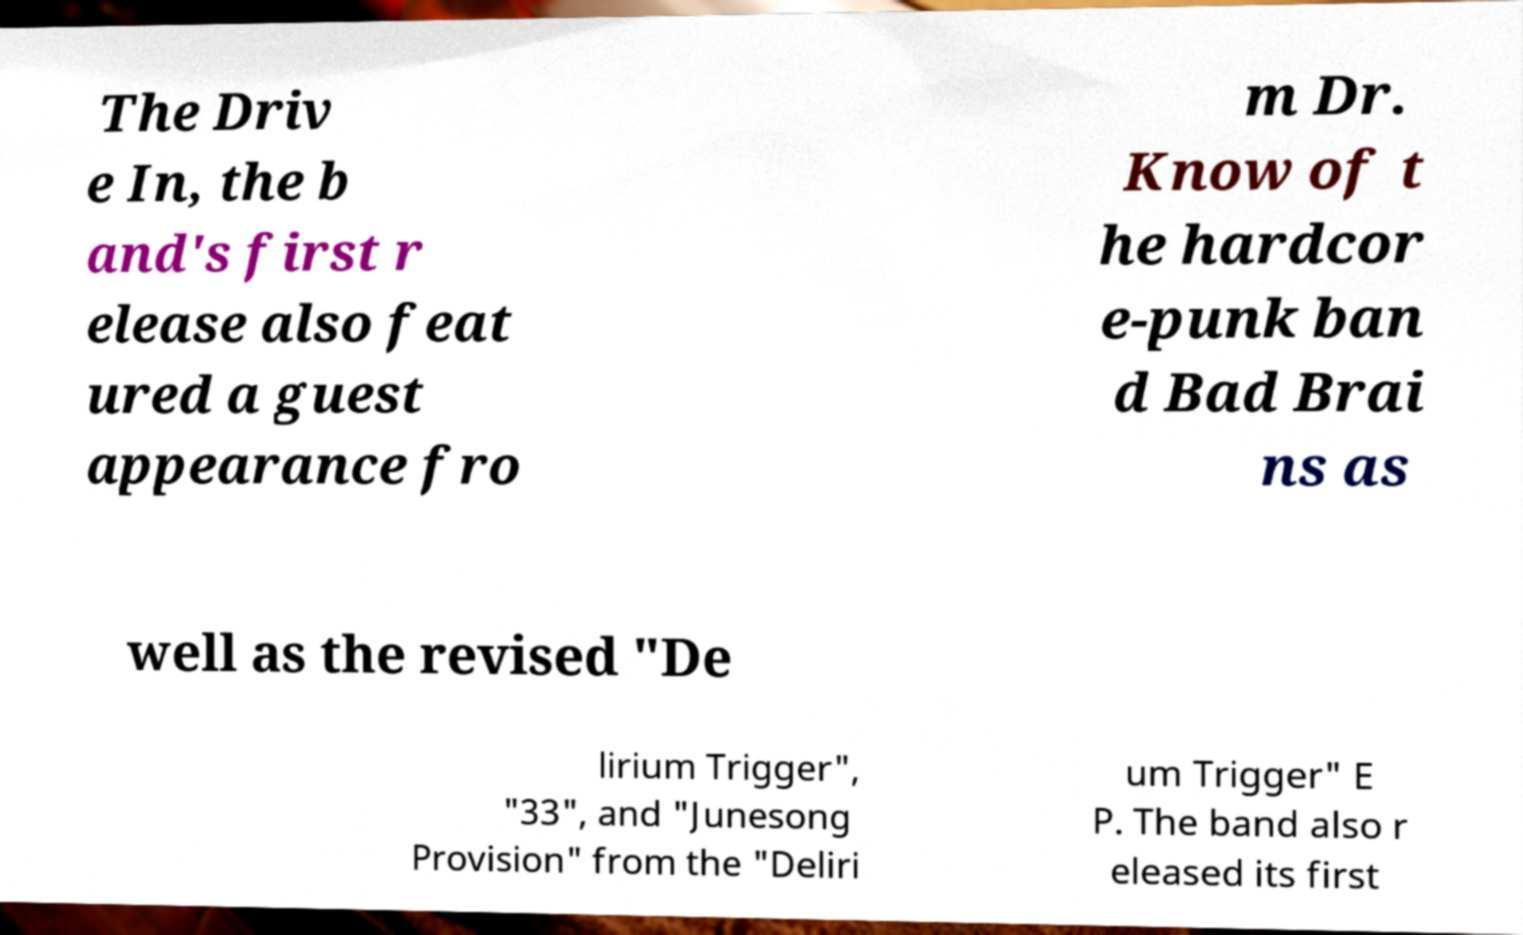Please read and relay the text visible in this image. What does it say? The Driv e In, the b and's first r elease also feat ured a guest appearance fro m Dr. Know of t he hardcor e-punk ban d Bad Brai ns as well as the revised "De lirium Trigger", "33", and "Junesong Provision" from the "Deliri um Trigger" E P. The band also r eleased its first 